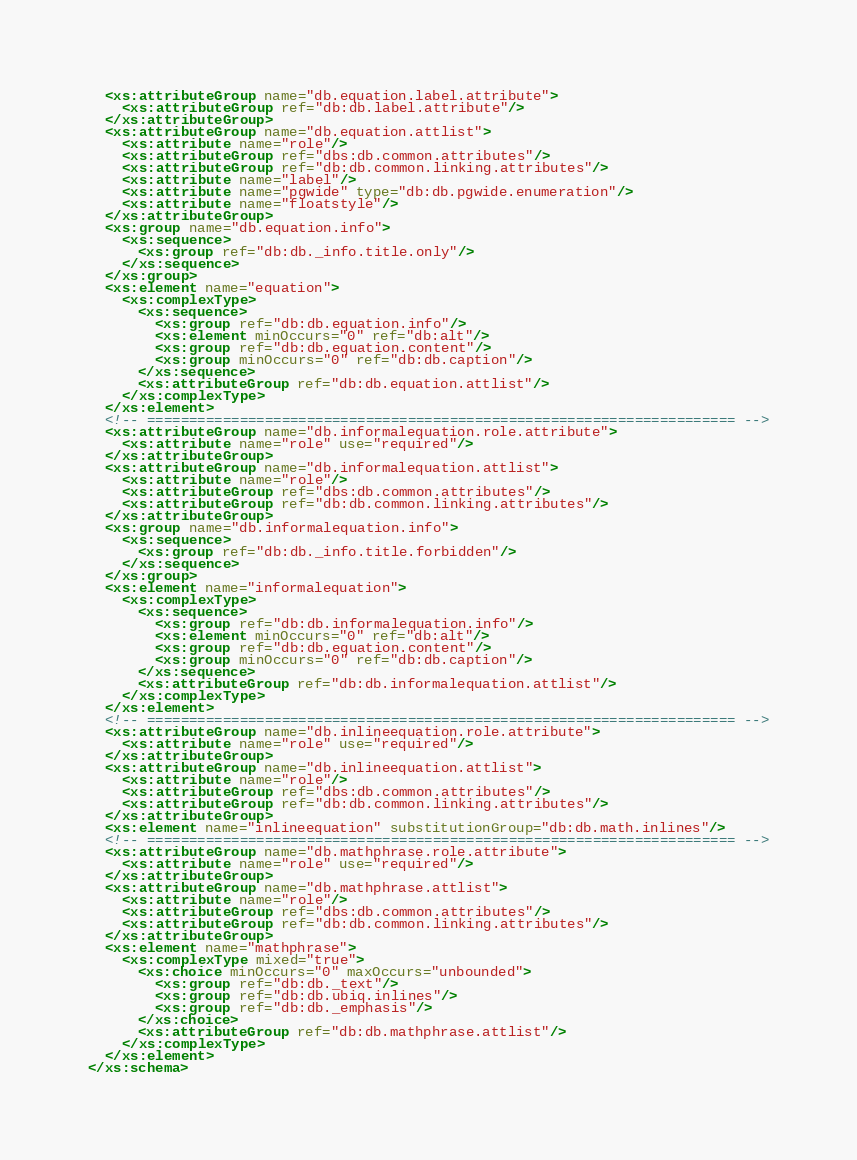Convert code to text. <code><loc_0><loc_0><loc_500><loc_500><_XML_>  <xs:attributeGroup name="db.equation.label.attribute">
    <xs:attributeGroup ref="db:db.label.attribute"/>
  </xs:attributeGroup>
  <xs:attributeGroup name="db.equation.attlist">
    <xs:attribute name="role"/>
    <xs:attributeGroup ref="dbs:db.common.attributes"/>
    <xs:attributeGroup ref="db:db.common.linking.attributes"/>
    <xs:attribute name="label"/>
    <xs:attribute name="pgwide" type="db:db.pgwide.enumeration"/>
    <xs:attribute name="floatstyle"/>
  </xs:attributeGroup>
  <xs:group name="db.equation.info">
    <xs:sequence>
      <xs:group ref="db:db._info.title.only"/>
    </xs:sequence>
  </xs:group>
  <xs:element name="equation">
    <xs:complexType>
      <xs:sequence>
        <xs:group ref="db:db.equation.info"/>
        <xs:element minOccurs="0" ref="db:alt"/>
        <xs:group ref="db:db.equation.content"/>
        <xs:group minOccurs="0" ref="db:db.caption"/>
      </xs:sequence>
      <xs:attributeGroup ref="db:db.equation.attlist"/>
    </xs:complexType>
  </xs:element>
  <!-- ====================================================================== -->
  <xs:attributeGroup name="db.informalequation.role.attribute">
    <xs:attribute name="role" use="required"/>
  </xs:attributeGroup>
  <xs:attributeGroup name="db.informalequation.attlist">
    <xs:attribute name="role"/>
    <xs:attributeGroup ref="dbs:db.common.attributes"/>
    <xs:attributeGroup ref="db:db.common.linking.attributes"/>
  </xs:attributeGroup>
  <xs:group name="db.informalequation.info">
    <xs:sequence>
      <xs:group ref="db:db._info.title.forbidden"/>
    </xs:sequence>
  </xs:group>
  <xs:element name="informalequation">
    <xs:complexType>
      <xs:sequence>
        <xs:group ref="db:db.informalequation.info"/>
        <xs:element minOccurs="0" ref="db:alt"/>
        <xs:group ref="db:db.equation.content"/>
        <xs:group minOccurs="0" ref="db:db.caption"/>
      </xs:sequence>
      <xs:attributeGroup ref="db:db.informalequation.attlist"/>
    </xs:complexType>
  </xs:element>
  <!-- ====================================================================== -->
  <xs:attributeGroup name="db.inlineequation.role.attribute">
    <xs:attribute name="role" use="required"/>
  </xs:attributeGroup>
  <xs:attributeGroup name="db.inlineequation.attlist">
    <xs:attribute name="role"/>
    <xs:attributeGroup ref="dbs:db.common.attributes"/>
    <xs:attributeGroup ref="db:db.common.linking.attributes"/>
  </xs:attributeGroup>
  <xs:element name="inlineequation" substitutionGroup="db:db.math.inlines"/>
  <!-- ====================================================================== -->
  <xs:attributeGroup name="db.mathphrase.role.attribute">
    <xs:attribute name="role" use="required"/>
  </xs:attributeGroup>
  <xs:attributeGroup name="db.mathphrase.attlist">
    <xs:attribute name="role"/>
    <xs:attributeGroup ref="dbs:db.common.attributes"/>
    <xs:attributeGroup ref="db:db.common.linking.attributes"/>
  </xs:attributeGroup>
  <xs:element name="mathphrase">
    <xs:complexType mixed="true">
      <xs:choice minOccurs="0" maxOccurs="unbounded">
        <xs:group ref="db:db._text"/>
        <xs:group ref="db:db.ubiq.inlines"/>
        <xs:group ref="db:db._emphasis"/>
      </xs:choice>
      <xs:attributeGroup ref="db:db.mathphrase.attlist"/>
    </xs:complexType>
  </xs:element>
</xs:schema>
</code> 